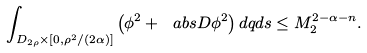<formula> <loc_0><loc_0><loc_500><loc_500>\int _ { D _ { 2 \rho } \times [ 0 , \rho ^ { 2 } / ( 2 \alpha ) ] } \left ( \phi ^ { 2 } + \ a b s { D \phi } ^ { 2 } \right ) d q d s \leq M _ { 2 } ^ { 2 - \alpha - n } .</formula> 